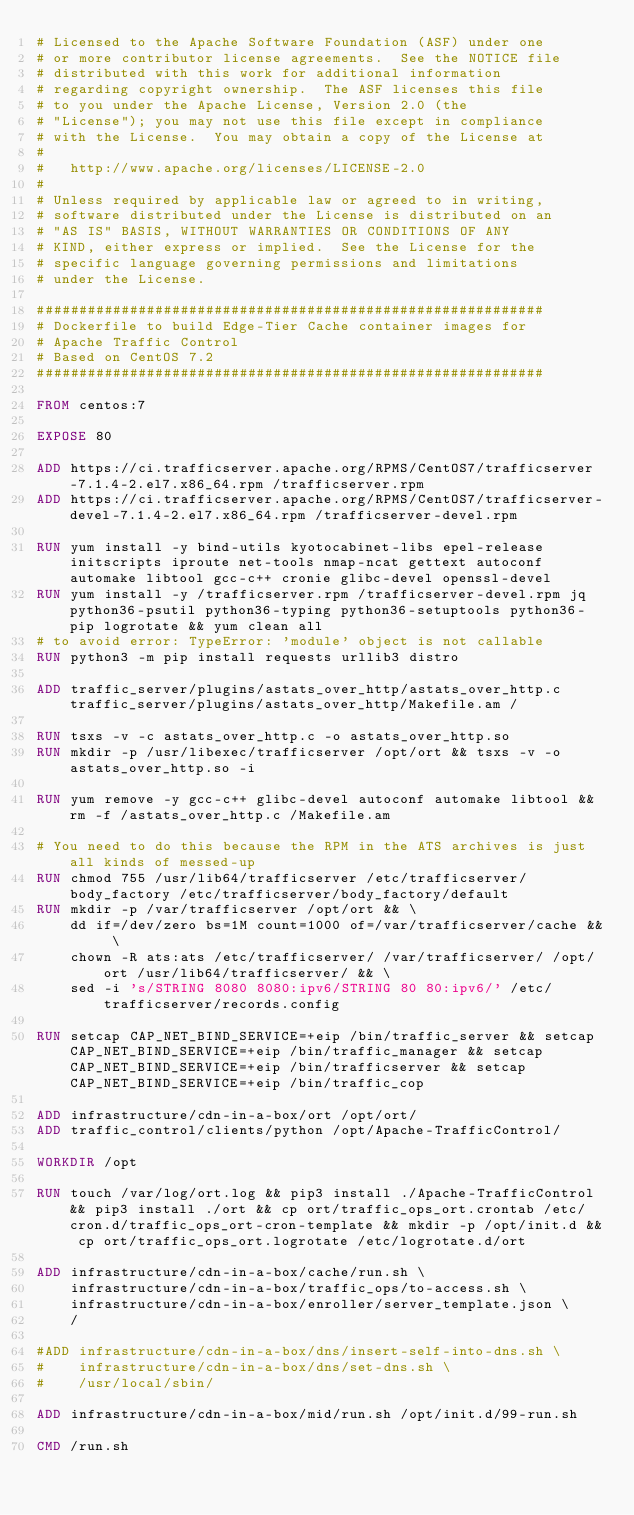Convert code to text. <code><loc_0><loc_0><loc_500><loc_500><_Dockerfile_># Licensed to the Apache Software Foundation (ASF) under one
# or more contributor license agreements.  See the NOTICE file
# distributed with this work for additional information
# regarding copyright ownership.  The ASF licenses this file
# to you under the Apache License, Version 2.0 (the
# "License"); you may not use this file except in compliance
# with the License.  You may obtain a copy of the License at
#
#   http://www.apache.org/licenses/LICENSE-2.0
#
# Unless required by applicable law or agreed to in writing,
# software distributed under the License is distributed on an
# "AS IS" BASIS, WITHOUT WARRANTIES OR CONDITIONS OF ANY
# KIND, either express or implied.  See the License for the
# specific language governing permissions and limitations
# under the License.

############################################################
# Dockerfile to build Edge-Tier Cache container images for
# Apache Traffic Control
# Based on CentOS 7.2
############################################################

FROM centos:7

EXPOSE 80

ADD https://ci.trafficserver.apache.org/RPMS/CentOS7/trafficserver-7.1.4-2.el7.x86_64.rpm /trafficserver.rpm
ADD https://ci.trafficserver.apache.org/RPMS/CentOS7/trafficserver-devel-7.1.4-2.el7.x86_64.rpm /trafficserver-devel.rpm

RUN yum install -y bind-utils kyotocabinet-libs epel-release initscripts iproute net-tools nmap-ncat gettext autoconf automake libtool gcc-c++ cronie glibc-devel openssl-devel
RUN yum install -y /trafficserver.rpm /trafficserver-devel.rpm jq python36-psutil python36-typing python36-setuptools python36-pip logrotate && yum clean all
# to avoid error: TypeError: 'module' object is not callable
RUN python3 -m pip install requests urllib3 distro

ADD traffic_server/plugins/astats_over_http/astats_over_http.c traffic_server/plugins/astats_over_http/Makefile.am /

RUN tsxs -v -c astats_over_http.c -o astats_over_http.so
RUN mkdir -p /usr/libexec/trafficserver /opt/ort && tsxs -v -o astats_over_http.so -i

RUN yum remove -y gcc-c++ glibc-devel autoconf automake libtool && rm -f /astats_over_http.c /Makefile.am

# You need to do this because the RPM in the ATS archives is just all kinds of messed-up
RUN chmod 755 /usr/lib64/trafficserver /etc/trafficserver/body_factory /etc/trafficserver/body_factory/default
RUN mkdir -p /var/trafficserver /opt/ort && \
    dd if=/dev/zero bs=1M count=1000 of=/var/trafficserver/cache && \
    chown -R ats:ats /etc/trafficserver/ /var/trafficserver/ /opt/ort /usr/lib64/trafficserver/ && \
    sed -i 's/STRING 8080 8080:ipv6/STRING 80 80:ipv6/' /etc/trafficserver/records.config

RUN setcap CAP_NET_BIND_SERVICE=+eip /bin/traffic_server && setcap CAP_NET_BIND_SERVICE=+eip /bin/traffic_manager && setcap CAP_NET_BIND_SERVICE=+eip /bin/trafficserver && setcap CAP_NET_BIND_SERVICE=+eip /bin/traffic_cop

ADD infrastructure/cdn-in-a-box/ort /opt/ort/
ADD traffic_control/clients/python /opt/Apache-TrafficControl/

WORKDIR /opt

RUN touch /var/log/ort.log && pip3 install ./Apache-TrafficControl && pip3 install ./ort && cp ort/traffic_ops_ort.crontab /etc/cron.d/traffic_ops_ort-cron-template && mkdir -p /opt/init.d && cp ort/traffic_ops_ort.logrotate /etc/logrotate.d/ort

ADD infrastructure/cdn-in-a-box/cache/run.sh \
    infrastructure/cdn-in-a-box/traffic_ops/to-access.sh \
    infrastructure/cdn-in-a-box/enroller/server_template.json \
    /

#ADD infrastructure/cdn-in-a-box/dns/insert-self-into-dns.sh \
#    infrastructure/cdn-in-a-box/dns/set-dns.sh \
#    /usr/local/sbin/

ADD infrastructure/cdn-in-a-box/mid/run.sh /opt/init.d/99-run.sh

CMD /run.sh
</code> 